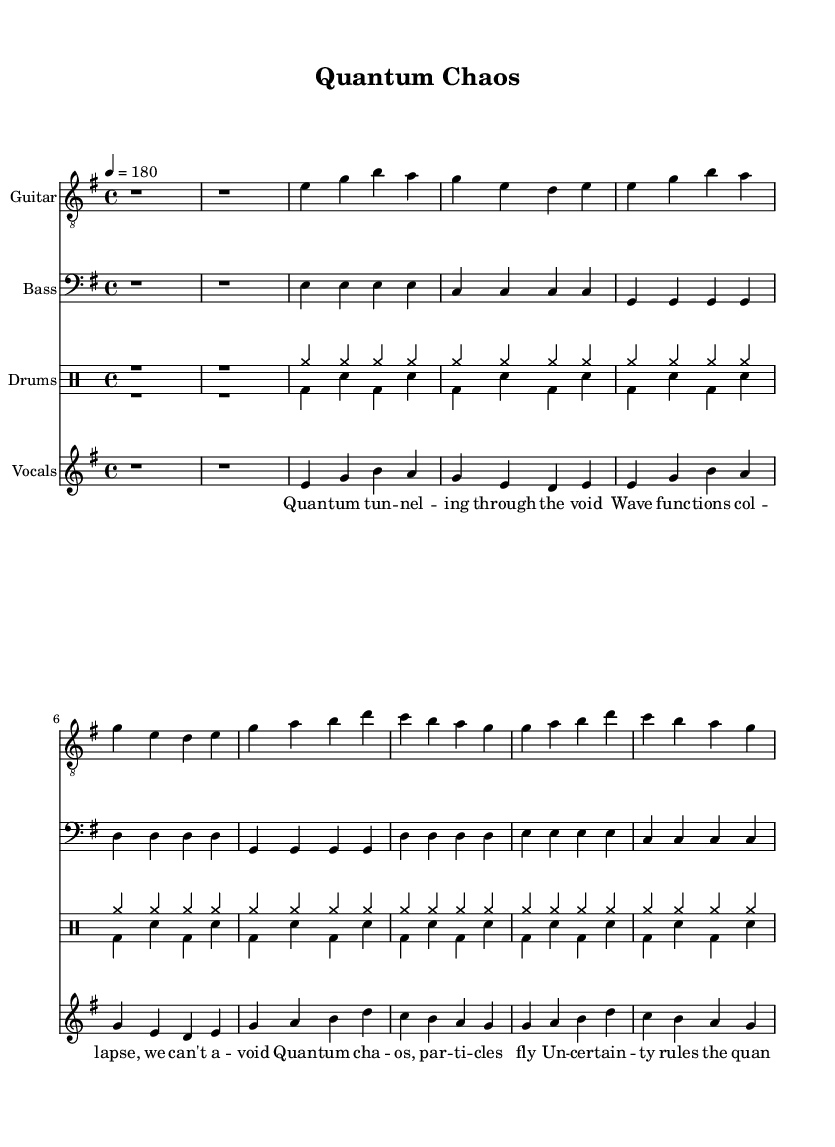What is the key signature of this music? The key signature is E minor, indicated by one sharp (F#) in the key signature area at the beginning of the sheet music.
Answer: E minor What is the time signature of this music? The time signature is 4/4, which is stated at the beginning of the score; this means there are four beats in each measure and the quarter note gets one beat.
Answer: 4/4 What is the tempo marking of this piece? The tempo marking indicates that the piece should be played at a speed of 180 beats per minute, as shown by "4 = 180" in the tempo text at the start of the score.
Answer: 180 How many measures are in the verse of the song? The verse consists of 8 measures, which can be counted from the verse section in the music for both guitar and vocals.
Answer: 8 What is the primary characteristic of the lyrics in this punk song? The lyrics showcase a strong thematic focus on quantum mechanics and particle physics, as seen in phrases like "quantum tuning through the void" and "quantum chaos, particles fly."
Answer: Quantum mechanics What type of drum patterns are used in the verse section? The drum patterns in the verse section exhibit a consistent use of cymbals and bass drums, with repeating patterns that create a driving punk rhythm, specifically seen in the grouped rhythms across the measures.
Answer: Cymbals and bass drums What is the vocal style reflected in the lyrics? The vocal style is aggressive and rhythmic, indicative of punk music, with the lyrics focusing on intense themes and a dynamic flow that lends itself to fast-paced delivery.
Answer: Aggressive and rhythmic 